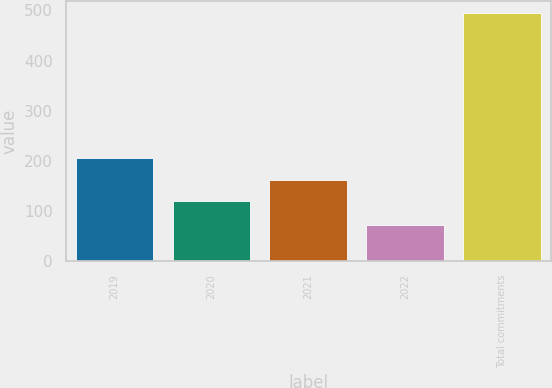Convert chart to OTSL. <chart><loc_0><loc_0><loc_500><loc_500><bar_chart><fcel>2019<fcel>2020<fcel>2021<fcel>2022<fcel>Total commitments<nl><fcel>205.2<fcel>121<fcel>163.1<fcel>73<fcel>494<nl></chart> 